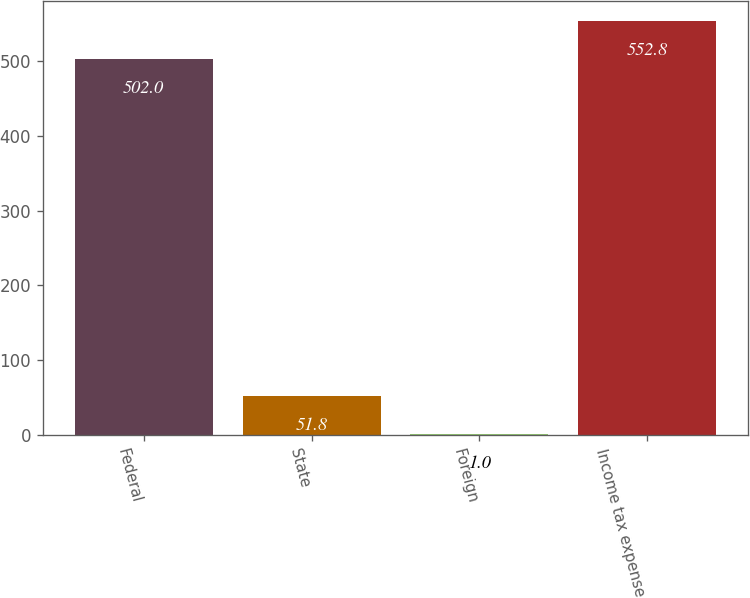<chart> <loc_0><loc_0><loc_500><loc_500><bar_chart><fcel>Federal<fcel>State<fcel>Foreign<fcel>Income tax expense<nl><fcel>502<fcel>51.8<fcel>1<fcel>552.8<nl></chart> 